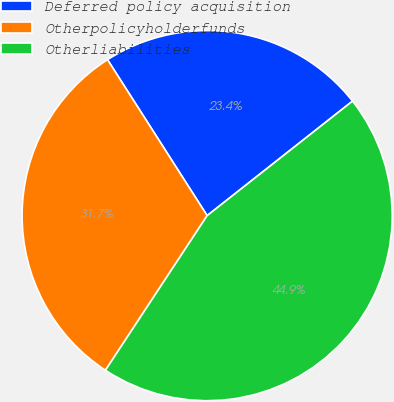<chart> <loc_0><loc_0><loc_500><loc_500><pie_chart><fcel>Deferred policy acquisition<fcel>Otherpolicyholderfunds<fcel>Otherliabilities<nl><fcel>23.43%<fcel>31.69%<fcel>44.88%<nl></chart> 